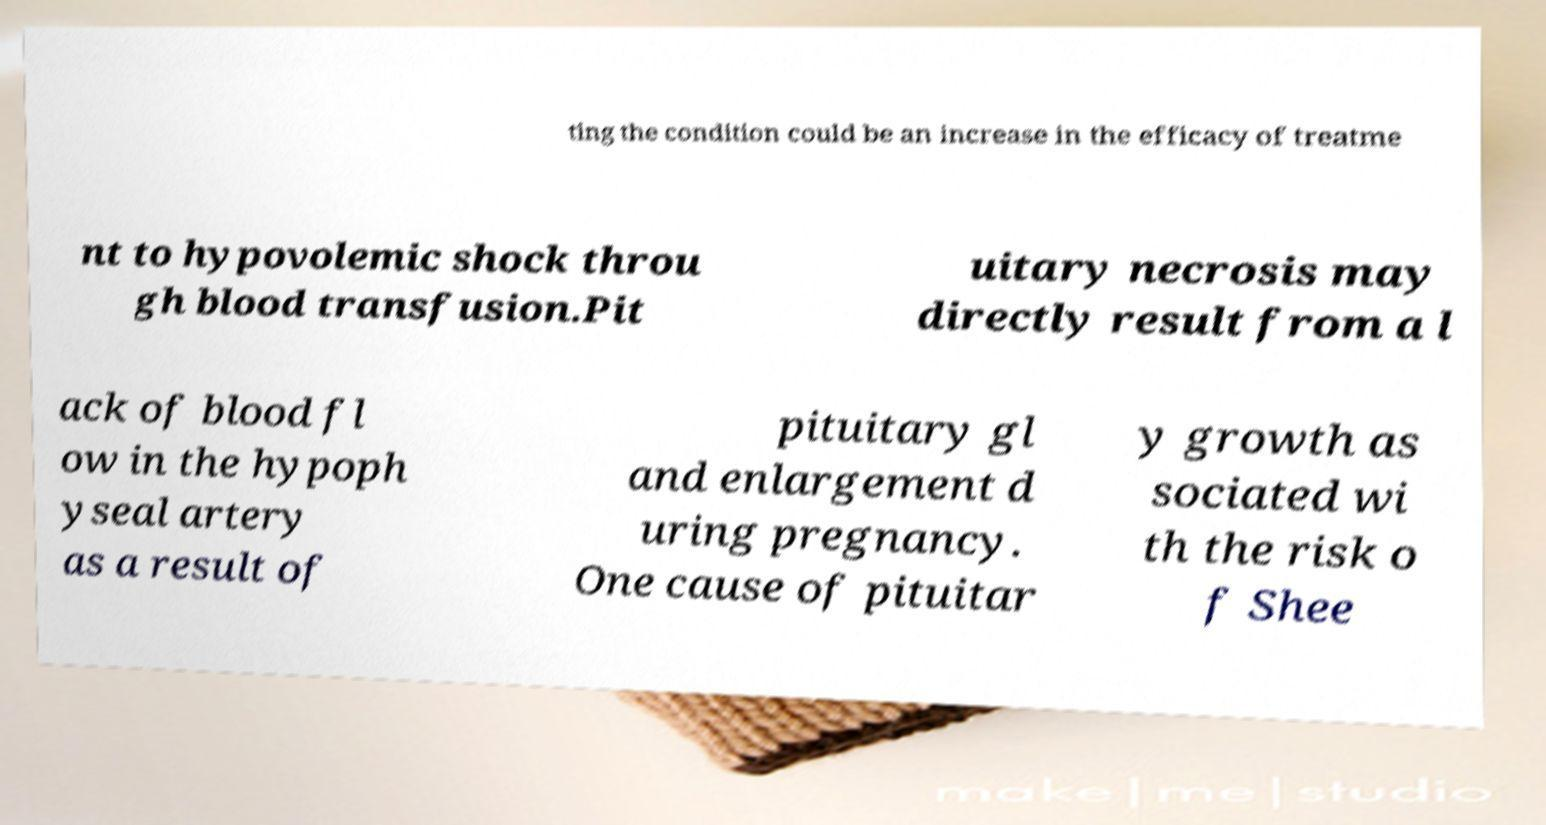For documentation purposes, I need the text within this image transcribed. Could you provide that? ting the condition could be an increase in the efficacy of treatme nt to hypovolemic shock throu gh blood transfusion.Pit uitary necrosis may directly result from a l ack of blood fl ow in the hypoph yseal artery as a result of pituitary gl and enlargement d uring pregnancy. One cause of pituitar y growth as sociated wi th the risk o f Shee 